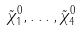<formula> <loc_0><loc_0><loc_500><loc_500>\tilde { \chi } _ { 1 } ^ { 0 } , \dots , \tilde { \chi } _ { 4 } ^ { 0 }</formula> 